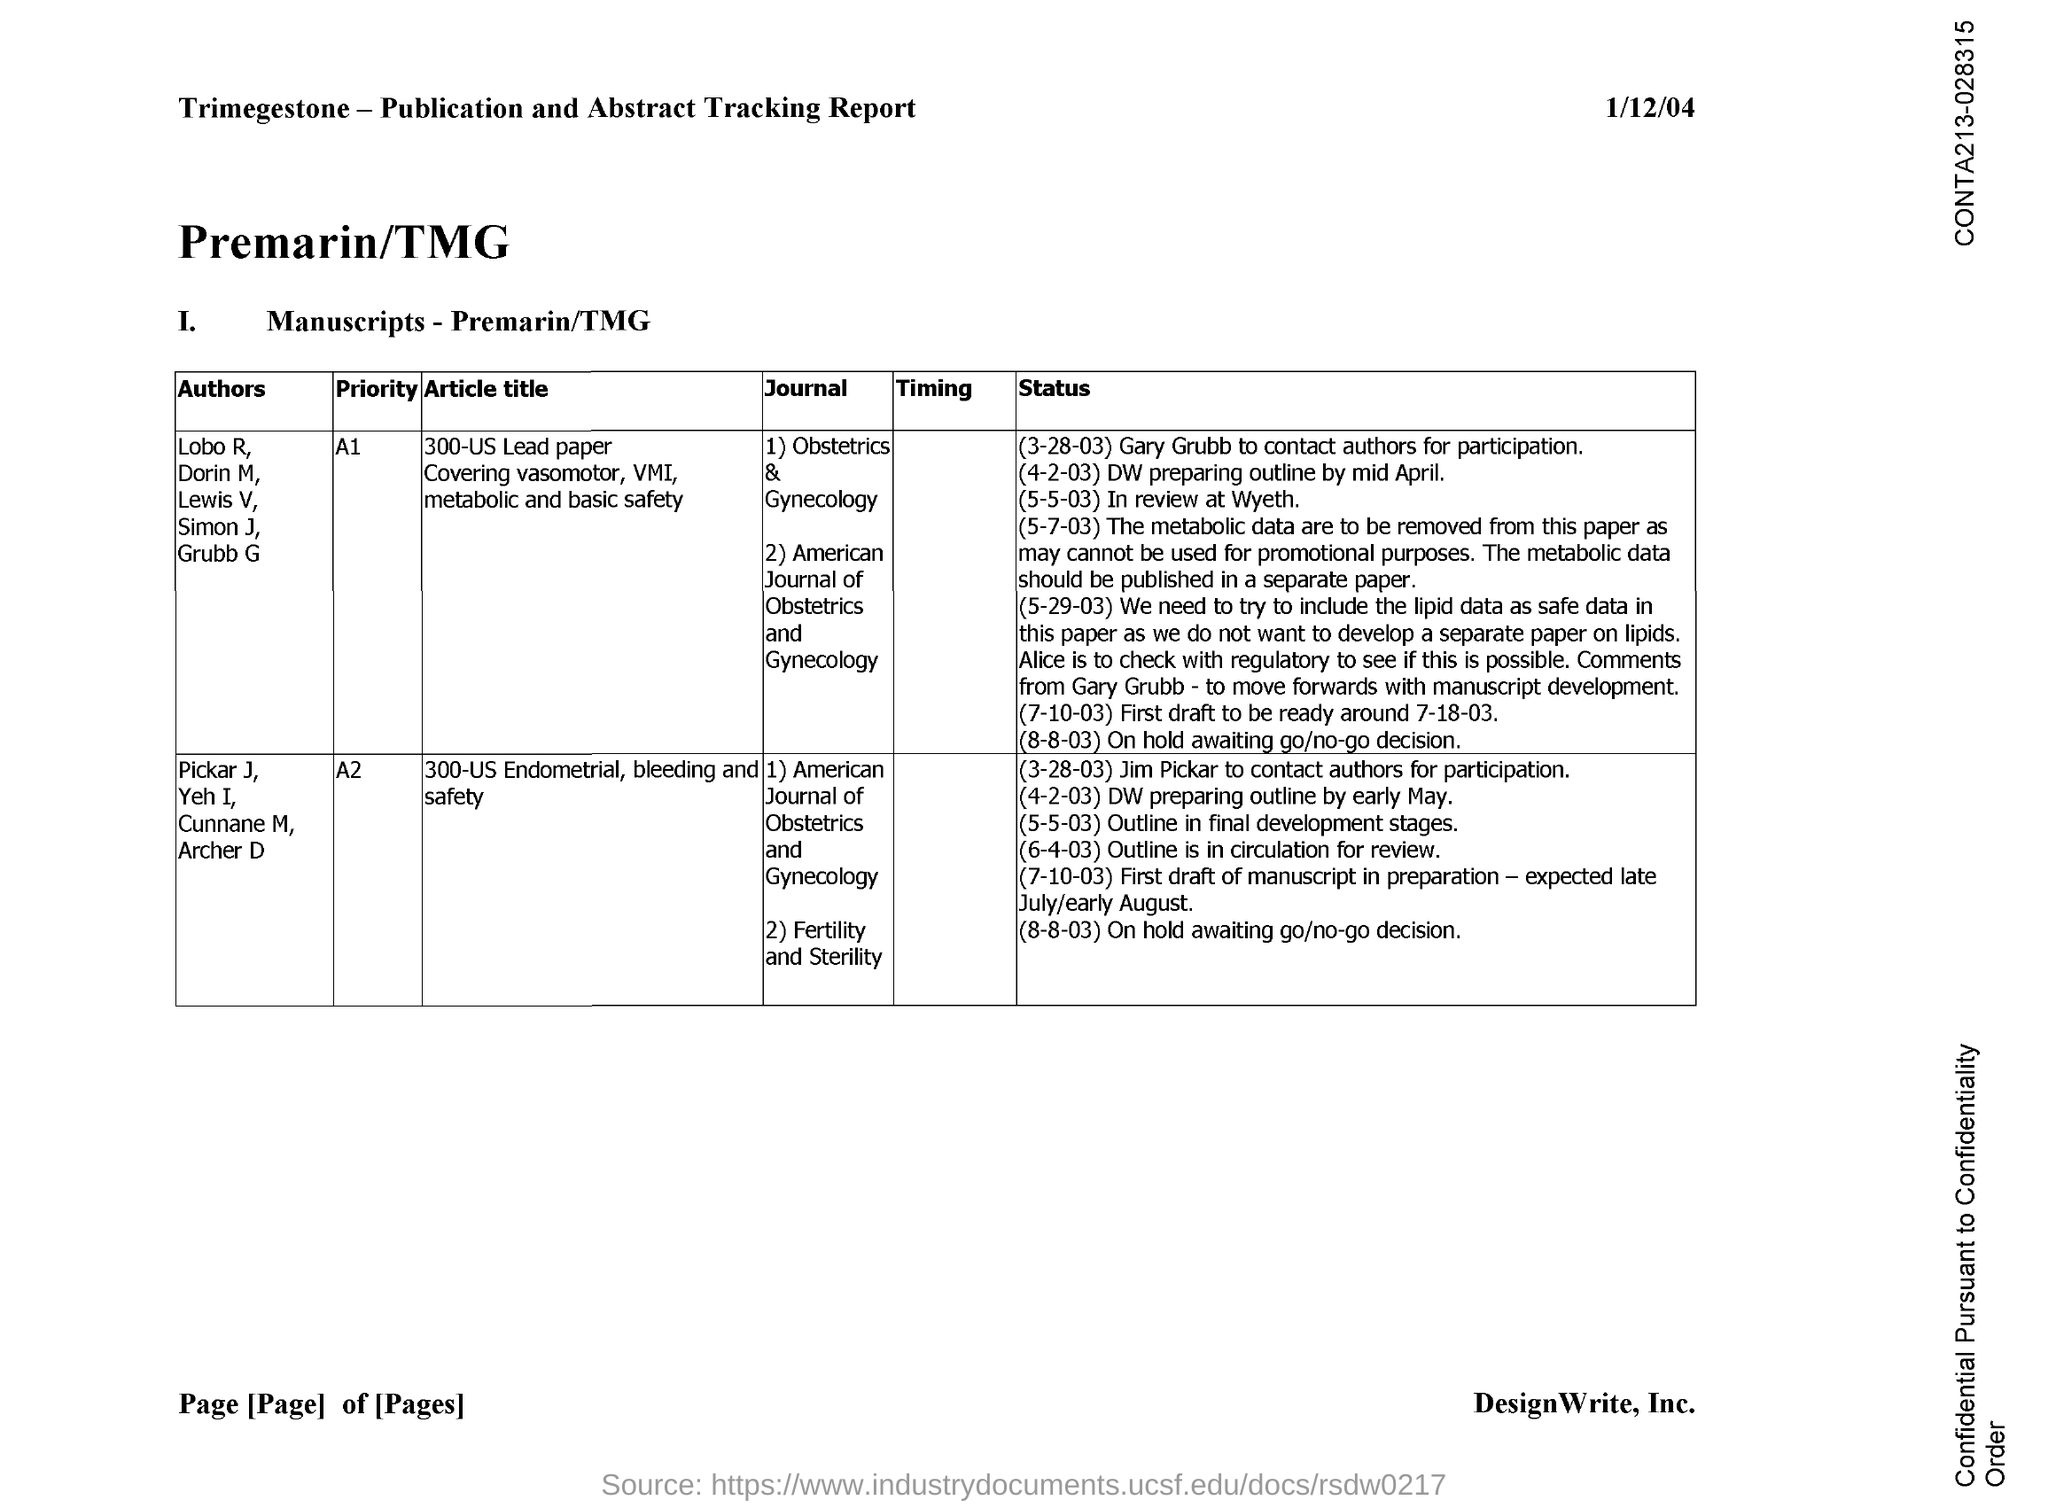What is the first journal on 300-US Lead Papercovering vasomotor, VMI, metabolic and basic safety
Ensure brevity in your answer.  OBSTETRICS & GYNECOLOGY. What is the priority of 300-us endometrial, bleeding and safety?
Ensure brevity in your answer.  A2. Which is the second journal on 300-us endometrial, bleeding and safety?
Offer a very short reply. Fertility and Sterility. What is the priority of 300-us lead paper covering vasomotor, vmi, metabolic and basic safety?
Offer a terse response. A1. What is the second journal on 300-US Lead Papercovering vasomotor, VMI, metabolic and basic safety
Keep it short and to the point. American journal of obstetrics and Gynecology. 